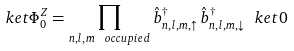<formula> <loc_0><loc_0><loc_500><loc_500>\ k e t { \Phi ^ { Z } _ { 0 } } = \prod _ { n , l , m \ o c c u p i e d } \hat { b } ^ { \dagger } _ { n , l , m , \uparrow } \, \hat { b } ^ { \dagger } _ { n , l , m , \downarrow } \ k e t { 0 }</formula> 